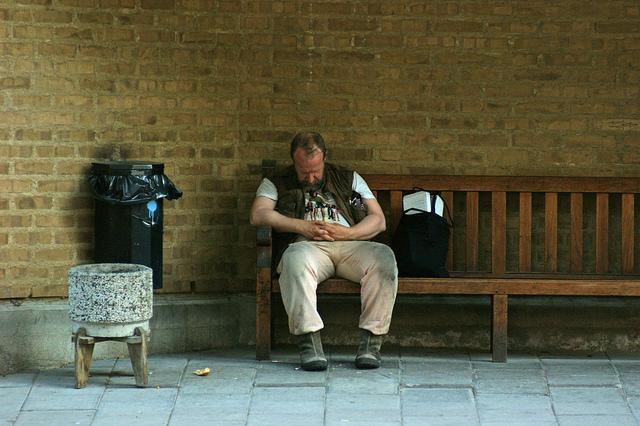How many backpacks can be seen?
Give a very brief answer. 1. How many people are in the photo?
Give a very brief answer. 1. How many carrots are there?
Give a very brief answer. 0. 